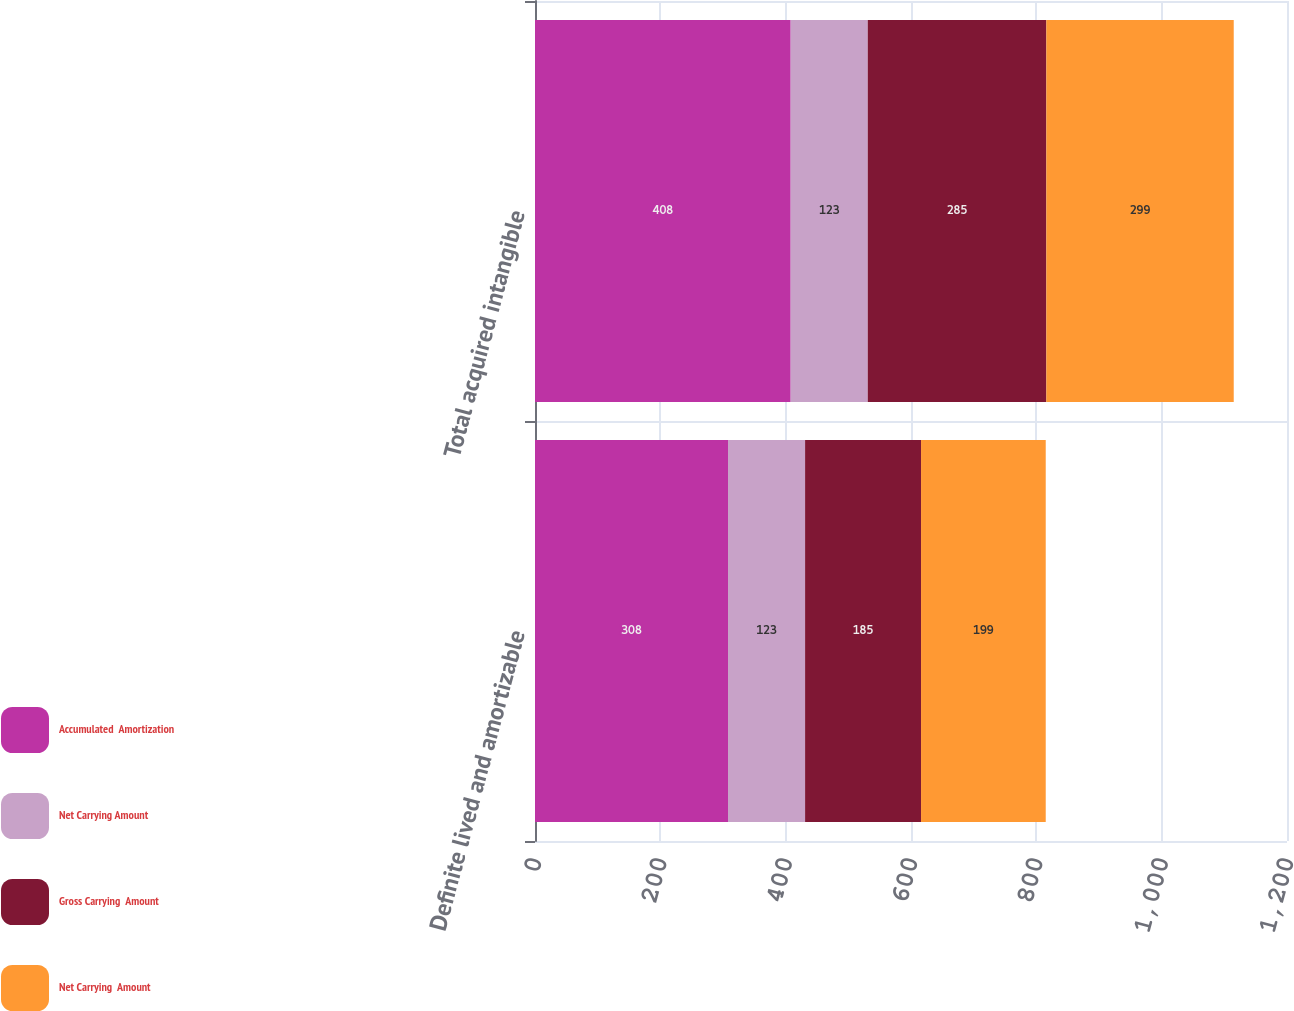<chart> <loc_0><loc_0><loc_500><loc_500><stacked_bar_chart><ecel><fcel>Definite lived and amortizable<fcel>Total acquired intangible<nl><fcel>Accumulated  Amortization<fcel>308<fcel>408<nl><fcel>Net Carrying Amount<fcel>123<fcel>123<nl><fcel>Gross Carrying  Amount<fcel>185<fcel>285<nl><fcel>Net Carrying  Amount<fcel>199<fcel>299<nl></chart> 